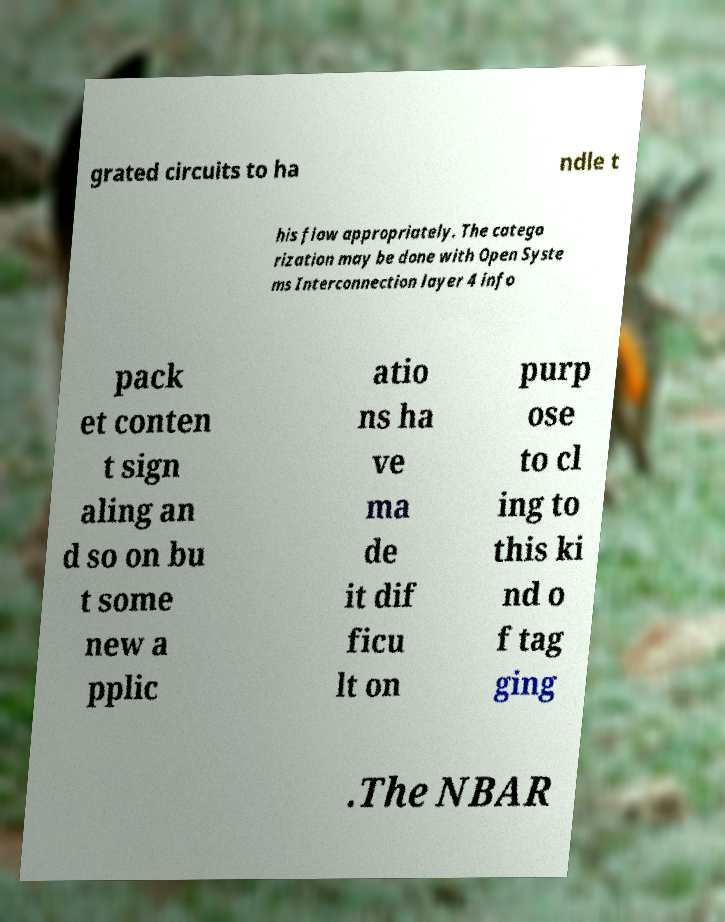I need the written content from this picture converted into text. Can you do that? grated circuits to ha ndle t his flow appropriately. The catego rization may be done with Open Syste ms Interconnection layer 4 info pack et conten t sign aling an d so on bu t some new a pplic atio ns ha ve ma de it dif ficu lt on purp ose to cl ing to this ki nd o f tag ging .The NBAR 